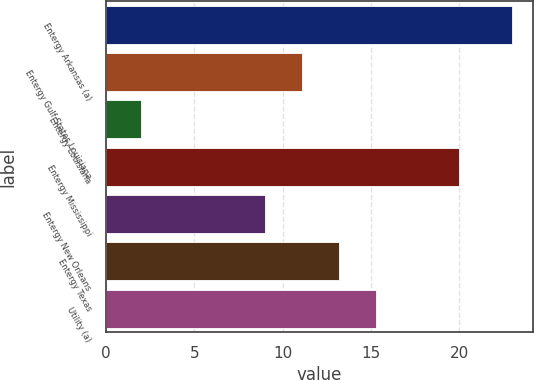Convert chart. <chart><loc_0><loc_0><loc_500><loc_500><bar_chart><fcel>Entergy Arkansas (a)<fcel>Entergy Gulf States Louisiana<fcel>Entergy Louisiana<fcel>Entergy Mississippi<fcel>Entergy New Orleans<fcel>Entergy Texas<fcel>Utility (a)<nl><fcel>23<fcel>11.1<fcel>2<fcel>20<fcel>9<fcel>13.2<fcel>15.3<nl></chart> 